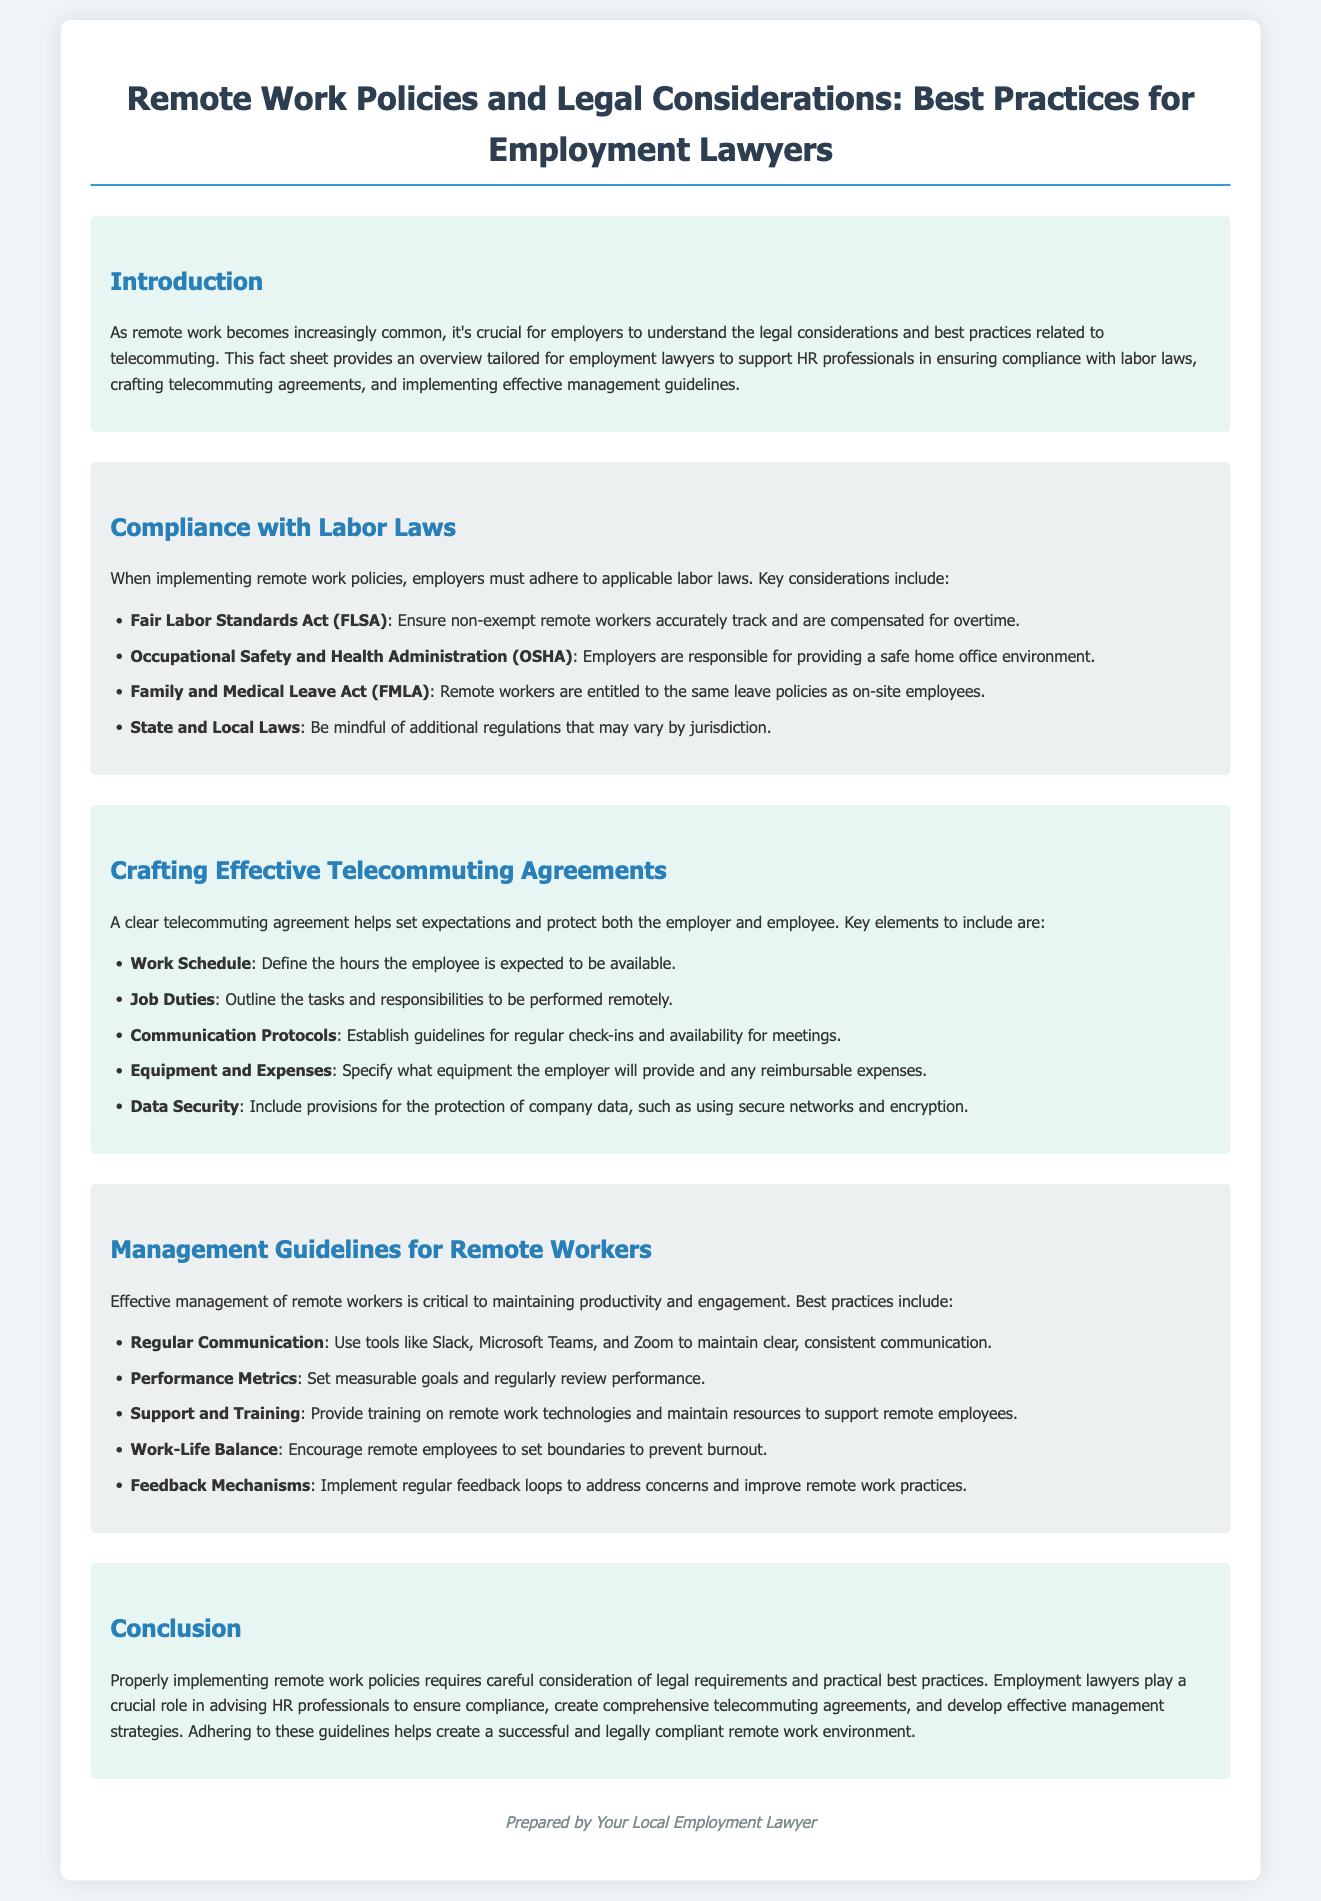What is the title of the document? The title is provided in the heading of the document.
Answer: Remote Work Policies and Legal Considerations: Best Practices for Employment Lawyers What does OSHA stand for? OSHA is mentioned as an important legal consideration in the document.
Answer: Occupational Safety and Health Administration What key element should be included in telecommuting agreements regarding employee availability? This information is highlighted under the section about telecommuting agreements.
Answer: Work Schedule Name one tool suggested for regular communication with remote workers. The document lists tools for maintaining communication, including examples.
Answer: Slack How many main sections are in the document? The main sections are outlined in the structure of the document itself.
Answer: Five What is one of the responsibilities outlined for employers regarding remote work? This information can be found under the compliance with labor laws section.
Answer: Providing a safe home office environment What is a recommended best practice for managing remote workers? This is derived from the management guidelines provided in the document.
Answer: Regular Communication What act specifies leave policies for remote workers? This information is included in the compliance section of the document.
Answer: Family and Medical Leave Act What is the purpose of this fact sheet? The purpose is described in the introduction of the document.
Answer: To support HR professionals in ensuring compliance with labor laws 